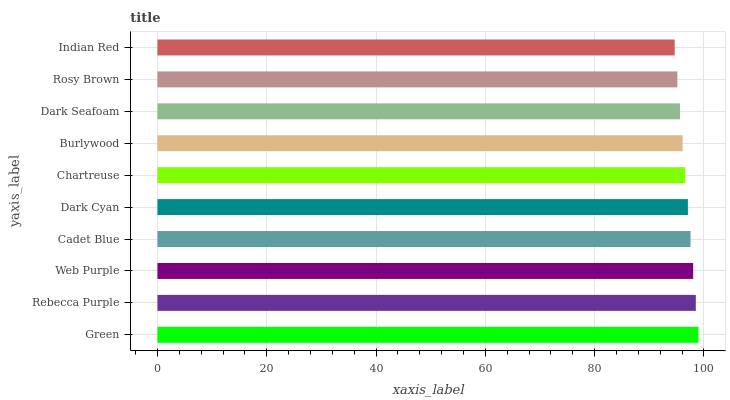Is Indian Red the minimum?
Answer yes or no. Yes. Is Green the maximum?
Answer yes or no. Yes. Is Rebecca Purple the minimum?
Answer yes or no. No. Is Rebecca Purple the maximum?
Answer yes or no. No. Is Green greater than Rebecca Purple?
Answer yes or no. Yes. Is Rebecca Purple less than Green?
Answer yes or no. Yes. Is Rebecca Purple greater than Green?
Answer yes or no. No. Is Green less than Rebecca Purple?
Answer yes or no. No. Is Dark Cyan the high median?
Answer yes or no. Yes. Is Chartreuse the low median?
Answer yes or no. Yes. Is Burlywood the high median?
Answer yes or no. No. Is Rosy Brown the low median?
Answer yes or no. No. 